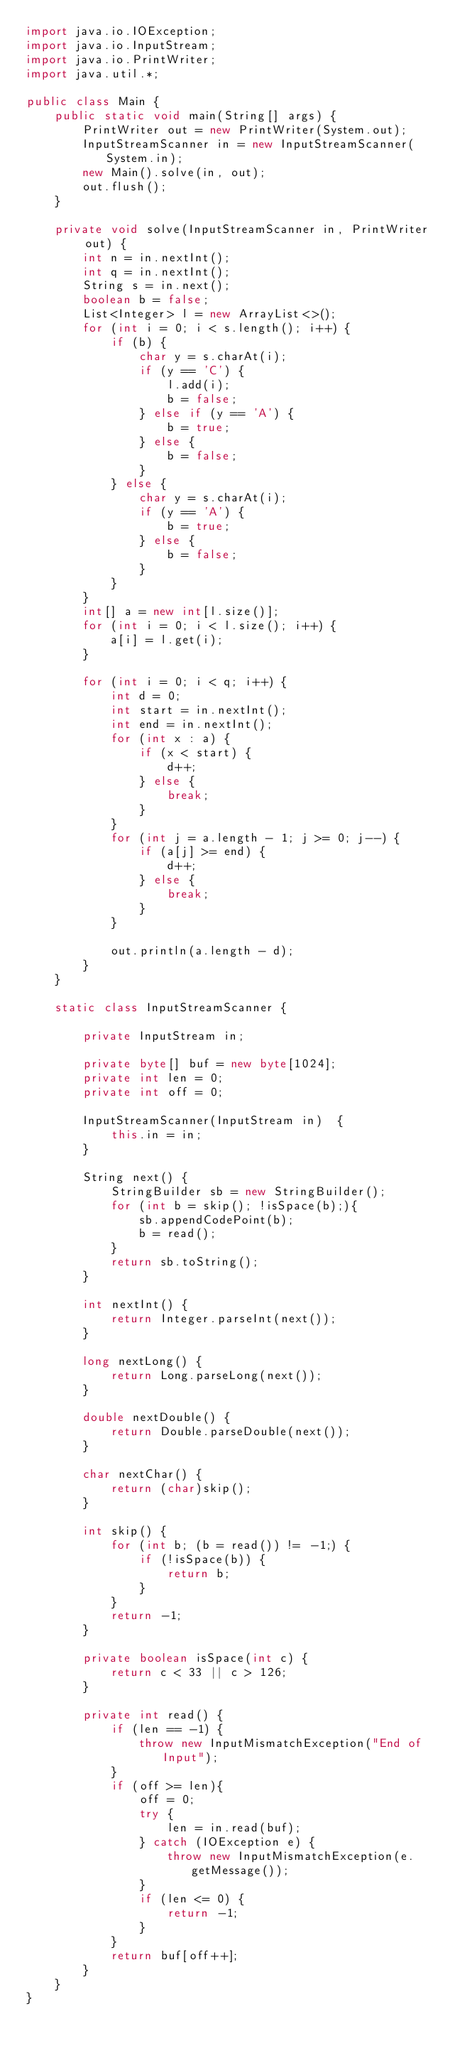<code> <loc_0><loc_0><loc_500><loc_500><_Java_>import java.io.IOException;
import java.io.InputStream;
import java.io.PrintWriter;
import java.util.*;

public class Main {
    public static void main(String[] args) {
        PrintWriter out = new PrintWriter(System.out);
        InputStreamScanner in = new InputStreamScanner(System.in);
        new Main().solve(in, out);
        out.flush();
    }

    private void solve(InputStreamScanner in, PrintWriter out) {
        int n = in.nextInt();
        int q = in.nextInt();
        String s = in.next();
        boolean b = false;
        List<Integer> l = new ArrayList<>();
        for (int i = 0; i < s.length(); i++) {
            if (b) {
                char y = s.charAt(i);
                if (y == 'C') {
                    l.add(i);
                    b = false;
                } else if (y == 'A') {
                    b = true;
                } else {
                    b = false;
                }
            } else {
                char y = s.charAt(i);
                if (y == 'A') {
                    b = true;
                } else {
                    b = false;
                }
            }
        }
        int[] a = new int[l.size()];
        for (int i = 0; i < l.size(); i++) {
            a[i] = l.get(i);
        }

        for (int i = 0; i < q; i++) {
            int d = 0;
            int start = in.nextInt();
            int end = in.nextInt();
            for (int x : a) {
                if (x < start) {
                    d++;
                } else {
                    break;
                }
            }
            for (int j = a.length - 1; j >= 0; j--) {
                if (a[j] >= end) {
                    d++;
                } else {
                    break;
                }
            }

            out.println(a.length - d);
        }
    }

    static class InputStreamScanner {

        private InputStream in;

        private byte[] buf = new byte[1024];
        private int len = 0;
        private int off = 0;

        InputStreamScanner(InputStream in)	{
            this.in = in;
        }

        String next() {
            StringBuilder sb = new StringBuilder();
            for (int b = skip(); !isSpace(b);){
                sb.appendCodePoint(b);
                b = read();
            }
            return sb.toString();
        }

        int nextInt() {
            return Integer.parseInt(next());
        }

        long nextLong() {
            return Long.parseLong(next());
        }

        double nextDouble() {
            return Double.parseDouble(next());
        }

        char nextChar() {
            return (char)skip();
        }

        int skip() {
            for (int b; (b = read()) != -1;) {
                if (!isSpace(b)) {
                    return b;
                }
            }
            return -1;
        }

        private boolean isSpace(int c) {
            return c < 33 || c > 126;
        }

        private int read() {
            if (len == -1) {
                throw new InputMismatchException("End of Input");
            }
            if (off >= len){
                off = 0;
                try {
                    len = in.read(buf);
                } catch (IOException e) {
                    throw new InputMismatchException(e.getMessage());
                }
                if (len <= 0) {
                    return -1;
                }
            }
            return buf[off++];
        }
    }
}</code> 